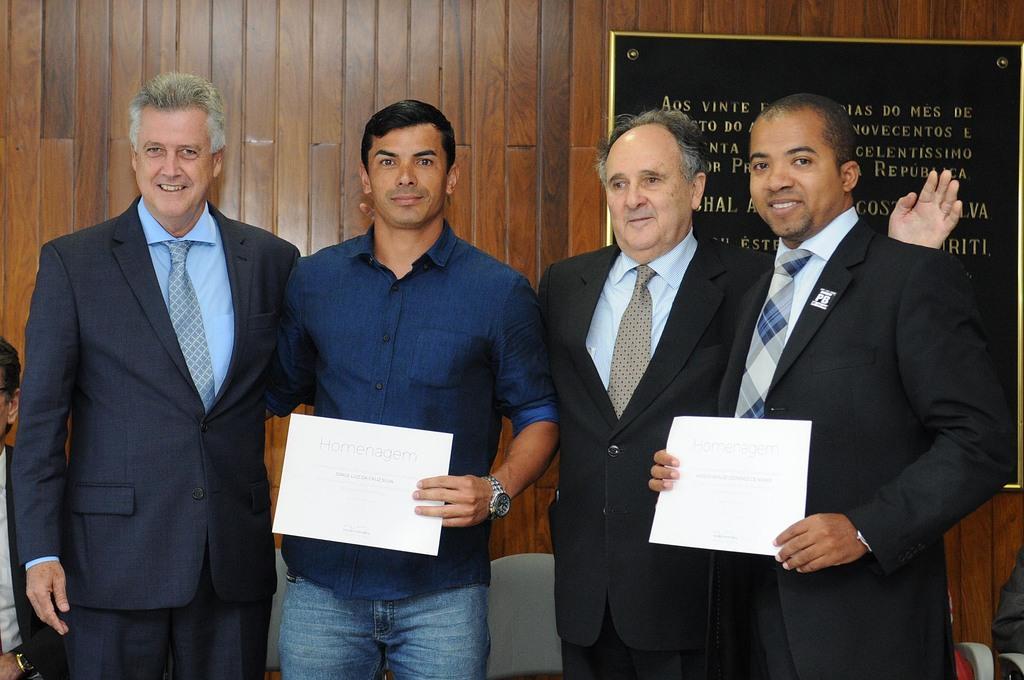How would you summarize this image in a sentence or two? In this image we can see this person wearing blue color shirt and wrist watch and this person wearing blazer and tie are holding papers in their hands and these two persons wearing blazers and ties are standing and smiling. In the background, we can see a board is fixed to the wooden wall. 